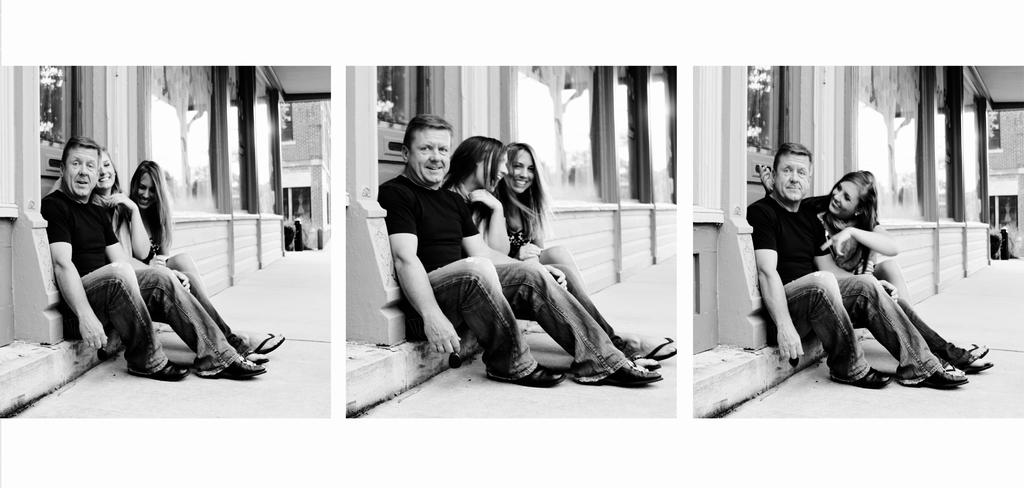What type of image is being described? The image is a photo collage. Who can be seen on the left side of the image? There is a man and two women sitting on the left side of the image. What are the people in the middle of the image doing? In the middle, there are three persons laughing. What type of architectural feature is present in the image? There are glass walls in the image. What type of clothing is worn by one of the persons in the image? One person is wearing a t-shirt and trousers. How many clocks can be seen in the image? There are no clocks visible in the image. What type of servant is present in the image? There is no servant present in the image. 